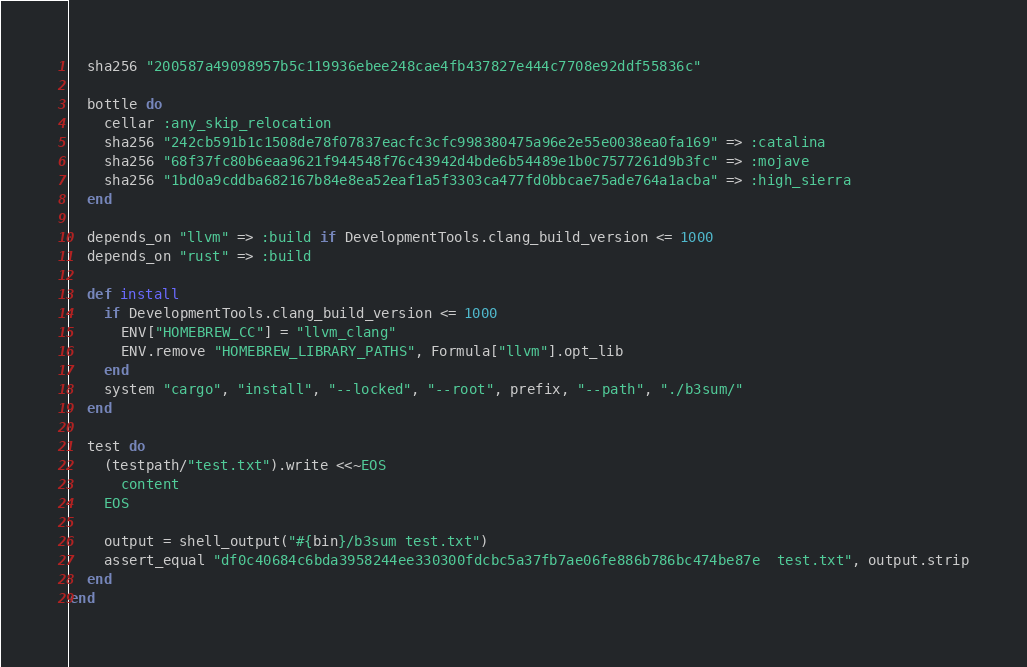<code> <loc_0><loc_0><loc_500><loc_500><_Ruby_>  sha256 "200587a49098957b5c119936ebee248cae4fb437827e444c7708e92ddf55836c"

  bottle do
    cellar :any_skip_relocation
    sha256 "242cb591b1c1508de78f07837eacfc3cfc998380475a96e2e55e0038ea0fa169" => :catalina
    sha256 "68f37fc80b6eaa9621f944548f76c43942d4bde6b54489e1b0c7577261d9b3fc" => :mojave
    sha256 "1bd0a9cddba682167b84e8ea52eaf1a5f3303ca477fd0bbcae75ade764a1acba" => :high_sierra
  end

  depends_on "llvm" => :build if DevelopmentTools.clang_build_version <= 1000
  depends_on "rust" => :build

  def install
    if DevelopmentTools.clang_build_version <= 1000
      ENV["HOMEBREW_CC"] = "llvm_clang"
      ENV.remove "HOMEBREW_LIBRARY_PATHS", Formula["llvm"].opt_lib
    end
    system "cargo", "install", "--locked", "--root", prefix, "--path", "./b3sum/"
  end

  test do
    (testpath/"test.txt").write <<~EOS
      content
    EOS

    output = shell_output("#{bin}/b3sum test.txt")
    assert_equal "df0c40684c6bda3958244ee330300fdcbc5a37fb7ae06fe886b786bc474be87e  test.txt", output.strip
  end
end
</code> 